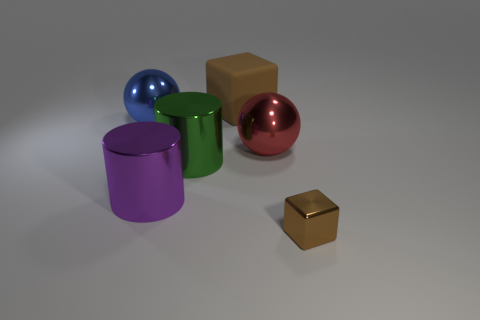Are there any tiny brown metal things that have the same shape as the big rubber thing?
Ensure brevity in your answer.  Yes. Do the purple cylinder and the cube that is behind the purple thing have the same material?
Provide a succinct answer. No. What material is the cube that is on the left side of the metal sphere on the right side of the matte cube?
Give a very brief answer. Rubber. Is the number of big purple objects that are to the left of the large brown block greater than the number of big blue blocks?
Ensure brevity in your answer.  Yes. Are any green metallic objects visible?
Your answer should be compact. Yes. What is the color of the large shiny cylinder behind the purple cylinder?
Make the answer very short. Green. There is a block that is the same size as the green metal thing; what is its material?
Give a very brief answer. Rubber. How many other objects are there of the same material as the big cube?
Provide a succinct answer. 0. The thing that is behind the large green shiny cylinder and right of the large brown object is what color?
Provide a short and direct response. Red. What number of things are brown things to the left of the tiny brown object or large purple shiny cylinders?
Your answer should be very brief. 2. 